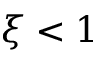Convert formula to latex. <formula><loc_0><loc_0><loc_500><loc_500>\xi < 1</formula> 